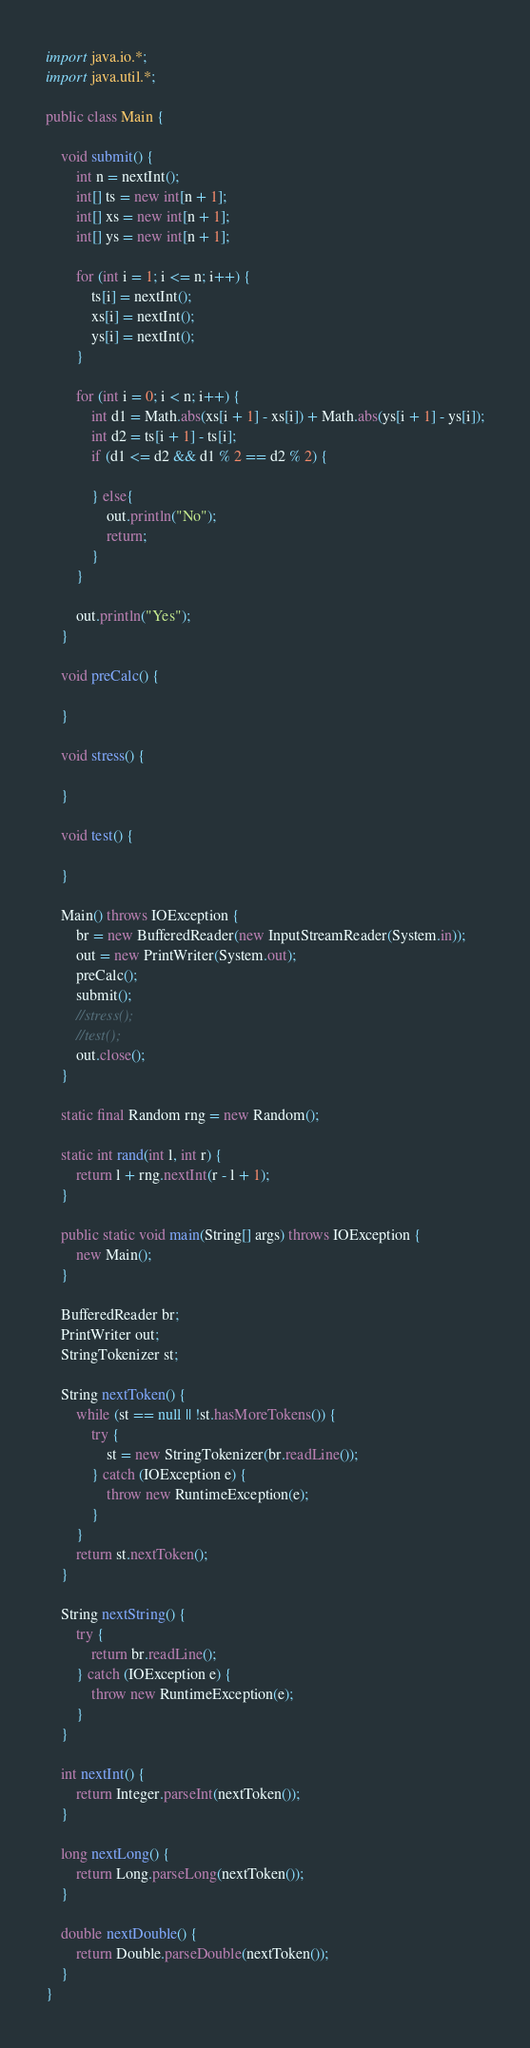Convert code to text. <code><loc_0><loc_0><loc_500><loc_500><_Java_>import java.io.*;
import java.util.*;

public class Main {

	void submit() {
		int n = nextInt();
		int[] ts = new int[n + 1];
		int[] xs = new int[n + 1];
		int[] ys = new int[n + 1];
		
		for (int i = 1; i <= n; i++) {
			ts[i] = nextInt();
			xs[i] = nextInt();
			ys[i] = nextInt();
		}
		
		for (int i = 0; i < n; i++) {
			int d1 = Math.abs(xs[i + 1] - xs[i]) + Math.abs(ys[i + 1] - ys[i]);
			int d2 = ts[i + 1] - ts[i];
			if (d1 <= d2 && d1 % 2 == d2 % 2) {
				
			} else{
				out.println("No");
				return;
			}
		}
		
		out.println("Yes");
	}

	void preCalc() {

	}

	void stress() {

	}

	void test() {

	}

	Main() throws IOException {
		br = new BufferedReader(new InputStreamReader(System.in));
		out = new PrintWriter(System.out);
		preCalc();
		submit();
		//stress();
		//test();
		out.close();
	}

	static final Random rng = new Random();

	static int rand(int l, int r) {
		return l + rng.nextInt(r - l + 1);
	}

	public static void main(String[] args) throws IOException {
		new Main();
	}

	BufferedReader br;
	PrintWriter out;
	StringTokenizer st;

	String nextToken() {
		while (st == null || !st.hasMoreTokens()) {
			try {
				st = new StringTokenizer(br.readLine());
			} catch (IOException e) {
				throw new RuntimeException(e);
			}
		}
		return st.nextToken();
	}

	String nextString() {
		try {
			return br.readLine();
		} catch (IOException e) {
			throw new RuntimeException(e);
		}
	}

	int nextInt() {
		return Integer.parseInt(nextToken());
	}

	long nextLong() {
		return Long.parseLong(nextToken());
	}

	double nextDouble() {
		return Double.parseDouble(nextToken());
	}
}
</code> 